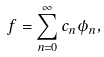<formula> <loc_0><loc_0><loc_500><loc_500>f = \sum _ { n = 0 } ^ { \infty } c _ { n } \phi _ { n } ,</formula> 